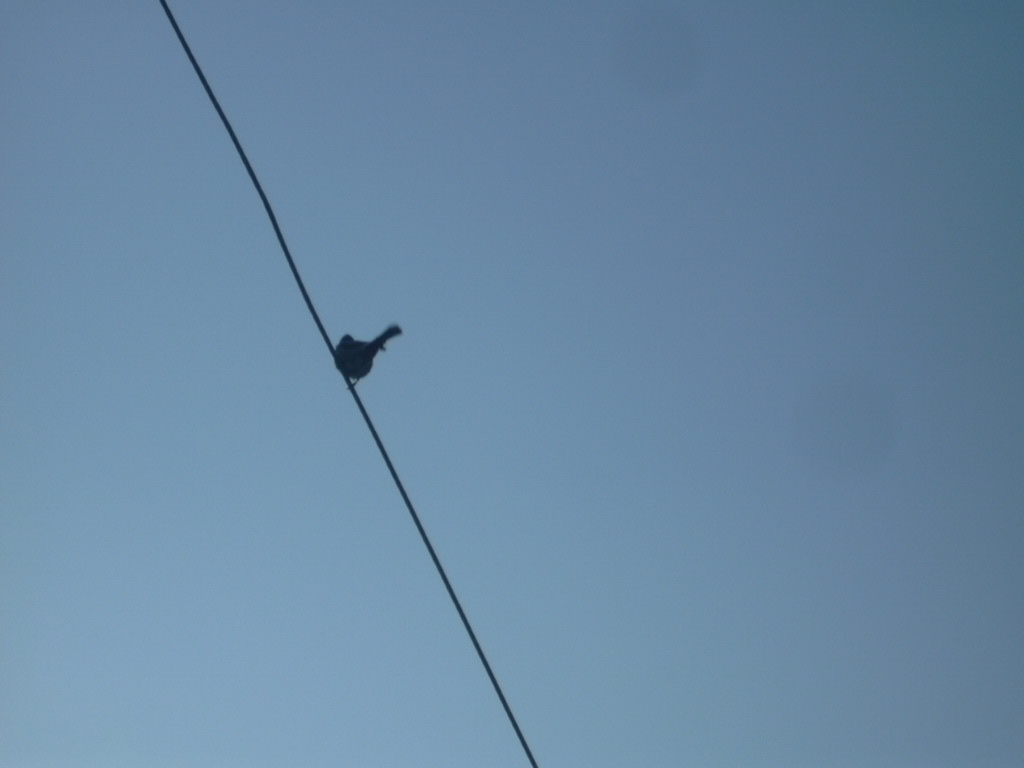What species of bird is on the wire? From this silhouette, it's challenging to determine the exact species without additional details, but it may be a common bird such as a pigeon or a starling. 